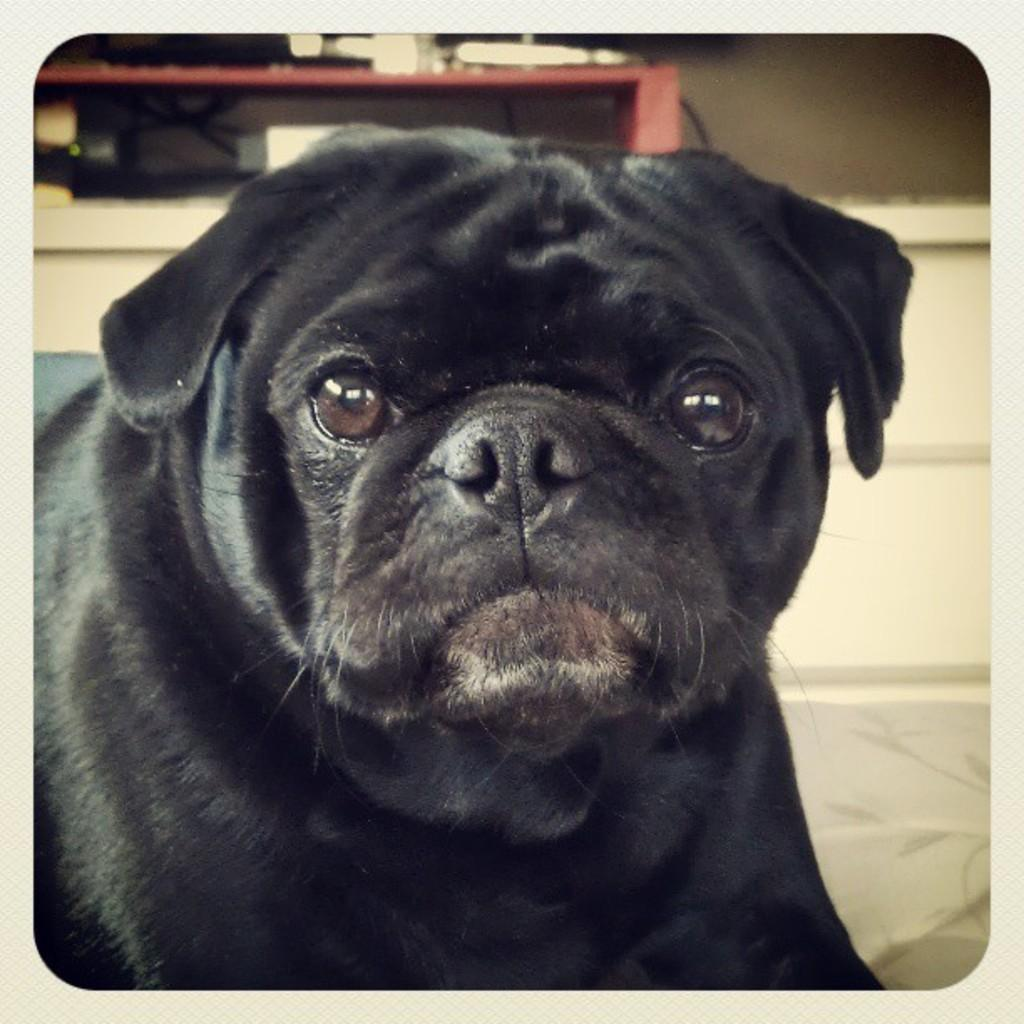What is the main subject in the center of the image? There is a dog in the center of the image. What can be seen in the background of the image? There is a wall and a table in the background of the image. How many legs does the mark have in the image? There is no mark present in the image, and therefore no legs can be counted. 